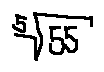Convert formula to latex. <formula><loc_0><loc_0><loc_500><loc_500>\sqrt { [ } 5 ] { 5 5 }</formula> 